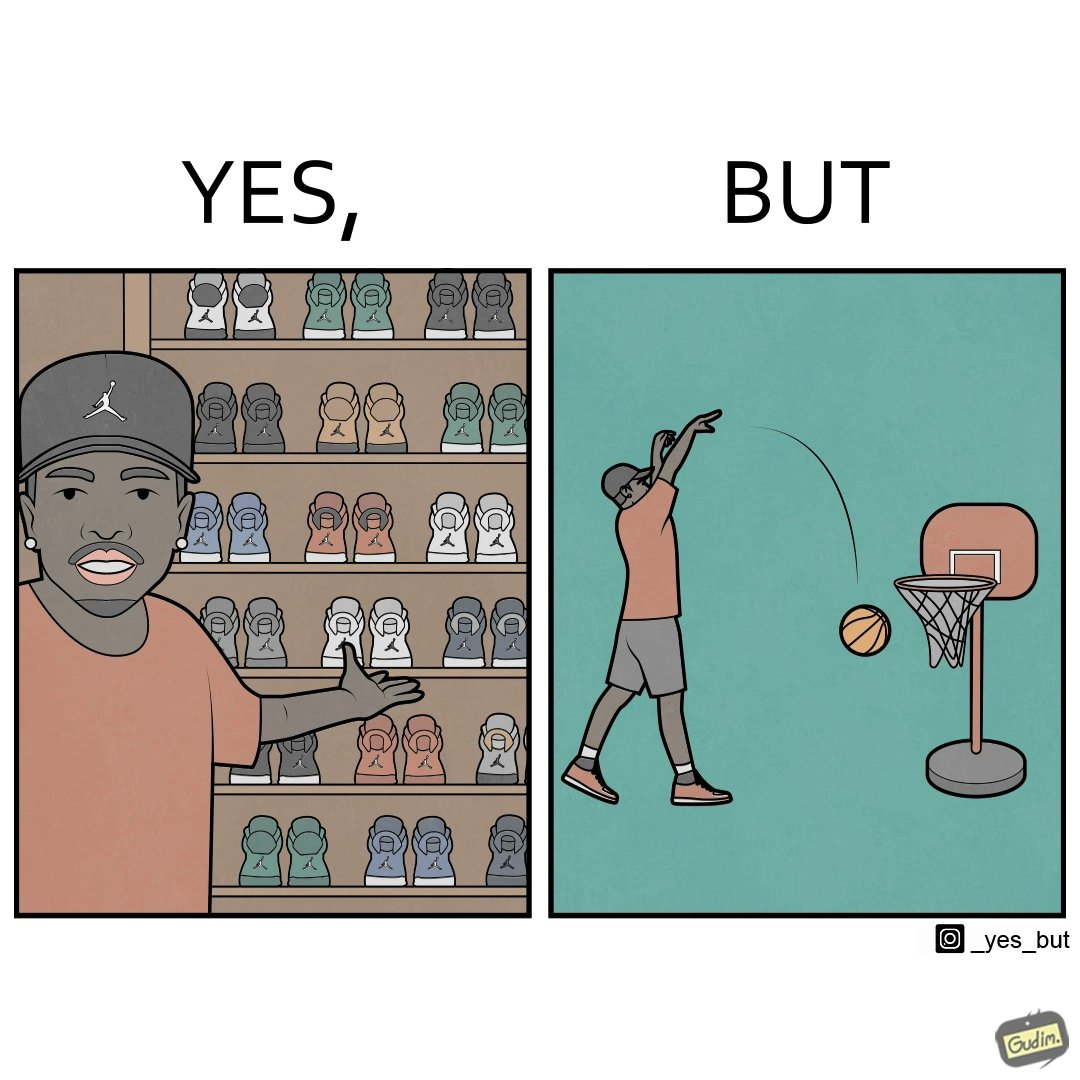Describe what you see in the left and right parts of this image. In the left part of the image: a person flexing his shoes collection In the right part of the image: a person not able to net a basketball even with a low height net 